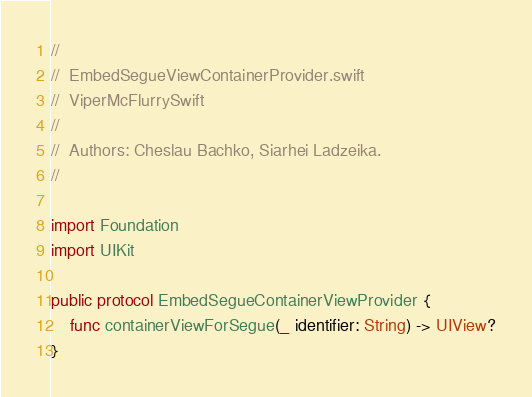<code> <loc_0><loc_0><loc_500><loc_500><_Swift_>//
//  EmbedSegueViewContainerProvider.swift
//  ViperMcFlurrySwift
//
//  Authors: Cheslau Bachko, Siarhei Ladzeika.
//

import Foundation
import UIKit

public protocol EmbedSegueContainerViewProvider {
    func containerViewForSegue(_ identifier: String) -> UIView?
}
</code> 